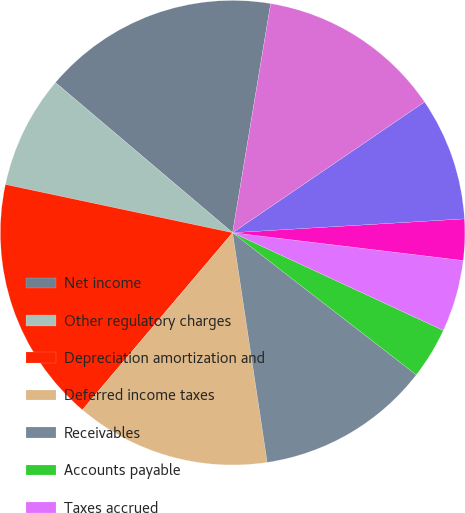<chart> <loc_0><loc_0><loc_500><loc_500><pie_chart><fcel>Net income<fcel>Other regulatory charges<fcel>Depreciation amortization and<fcel>Deferred income taxes<fcel>Receivables<fcel>Accounts payable<fcel>Taxes accrued<fcel>Interest accrued<fcel>Deferred fuel costs<fcel>Other working capital accounts<nl><fcel>16.43%<fcel>7.86%<fcel>17.14%<fcel>13.57%<fcel>12.14%<fcel>3.57%<fcel>5.0%<fcel>2.86%<fcel>8.57%<fcel>12.86%<nl></chart> 